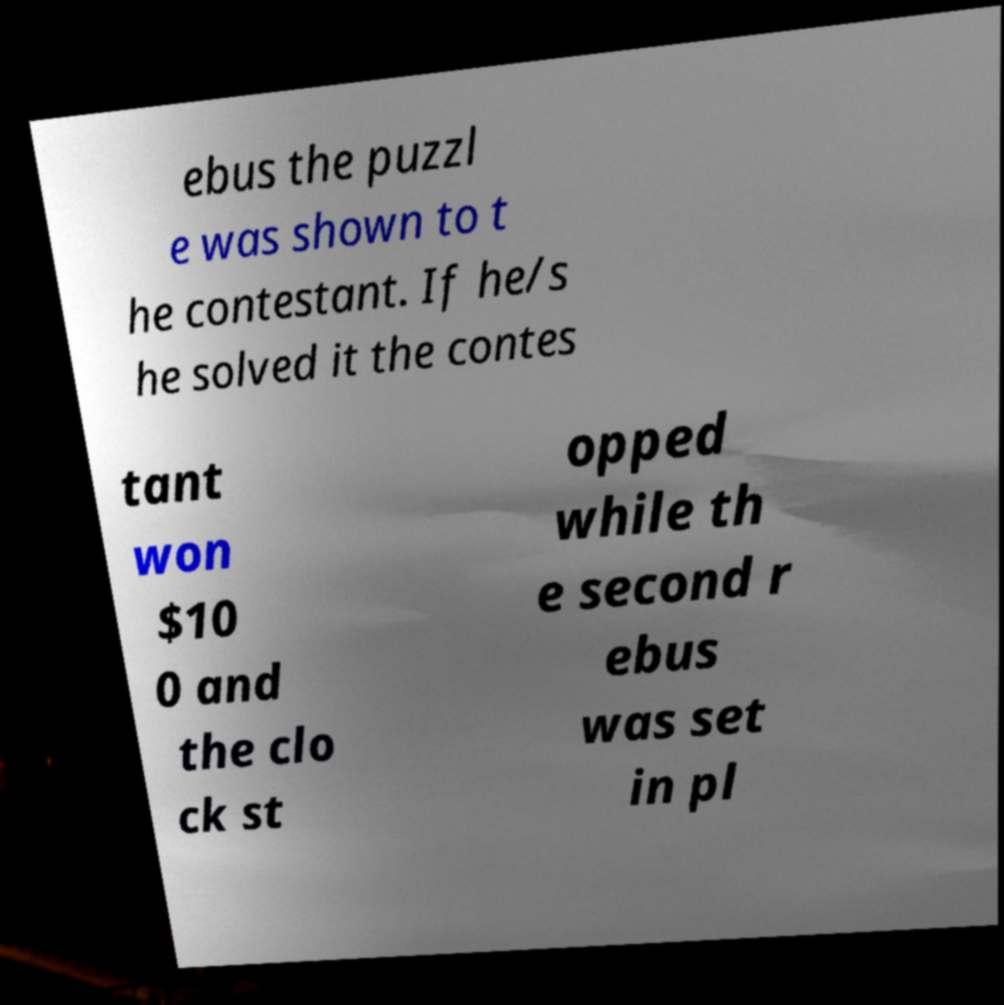Please read and relay the text visible in this image. What does it say? ebus the puzzl e was shown to t he contestant. If he/s he solved it the contes tant won $10 0 and the clo ck st opped while th e second r ebus was set in pl 